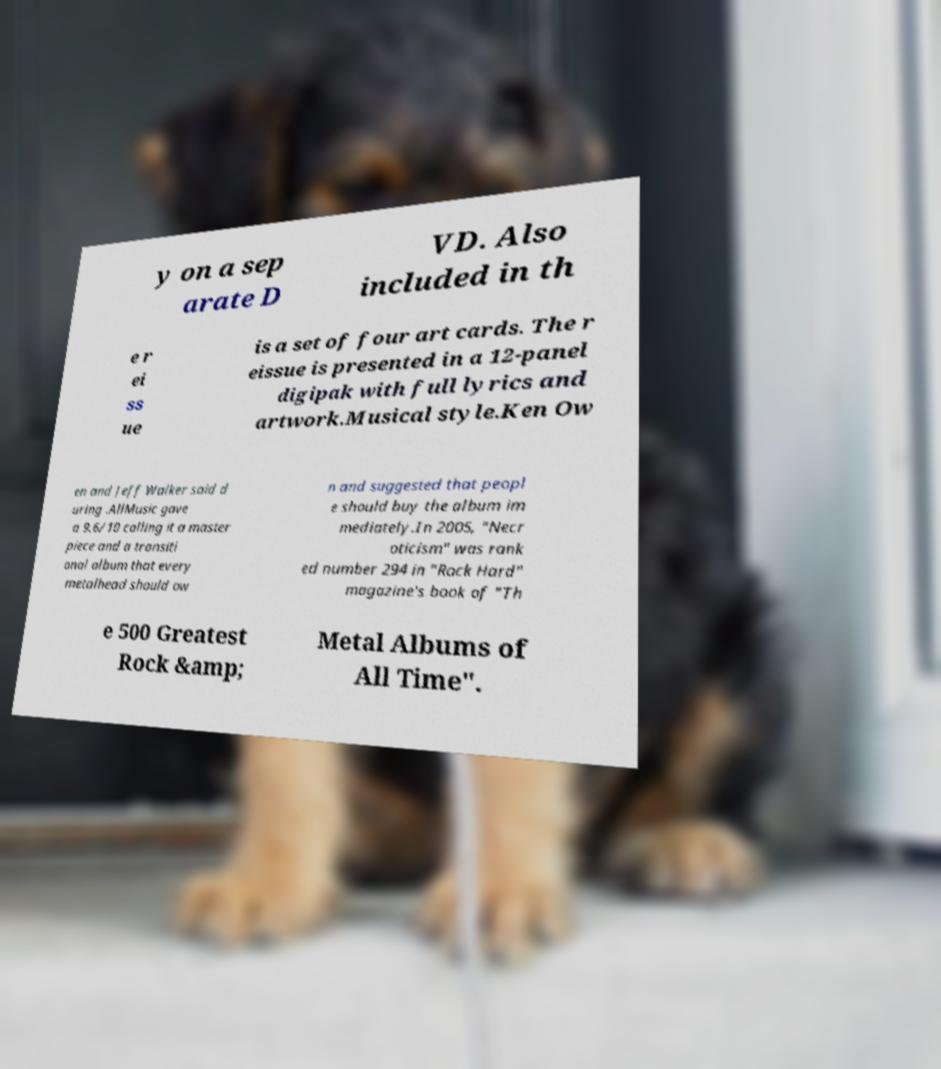For documentation purposes, I need the text within this image transcribed. Could you provide that? y on a sep arate D VD. Also included in th e r ei ss ue is a set of four art cards. The r eissue is presented in a 12-panel digipak with full lyrics and artwork.Musical style.Ken Ow en and Jeff Walker said d uring .AllMusic gave a 9.6/10 calling it a master piece and a transiti onal album that every metalhead should ow n and suggested that peopl e should buy the album im mediately.In 2005, "Necr oticism" was rank ed number 294 in "Rock Hard" magazine's book of "Th e 500 Greatest Rock &amp; Metal Albums of All Time". 